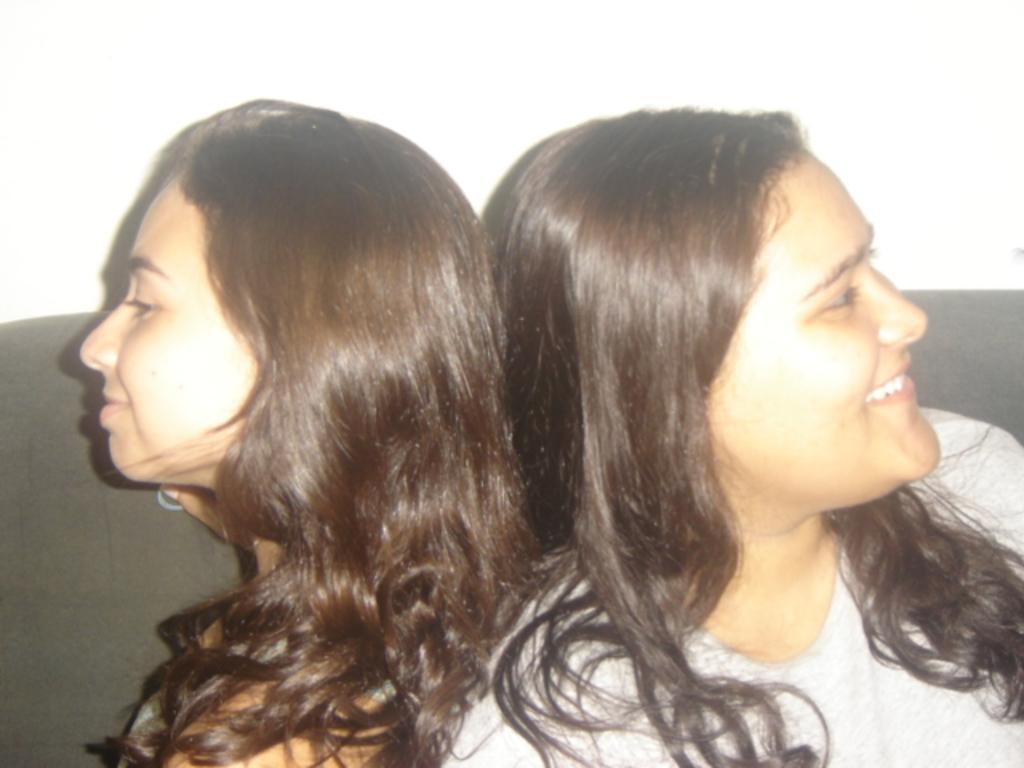How would you summarize this image in a sentence or two? In this image we can see women sitting and one of them is smiling. 